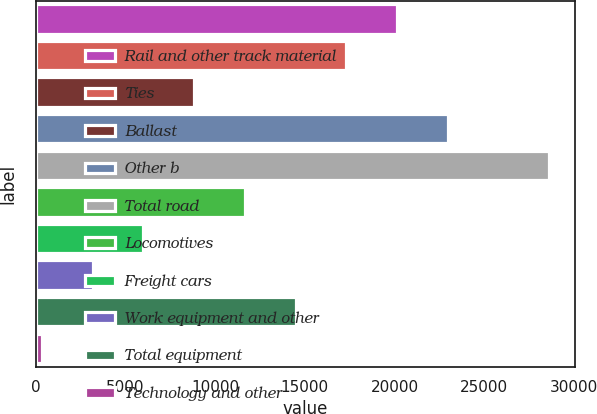<chart> <loc_0><loc_0><loc_500><loc_500><bar_chart><fcel>Rail and other track material<fcel>Ties<fcel>Ballast<fcel>Other b<fcel>Total road<fcel>Locomotives<fcel>Freight cars<fcel>Work equipment and other<fcel>Total equipment<fcel>Technology and other<nl><fcel>20135.1<fcel>17308.8<fcel>8829.9<fcel>22961.4<fcel>28614<fcel>11656.2<fcel>6003.6<fcel>3177.3<fcel>14482.5<fcel>351<nl></chart> 